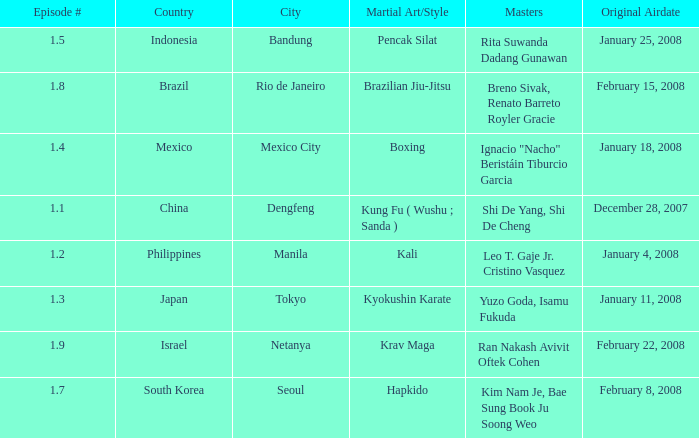How many masters fought using a boxing style? 1.0. 